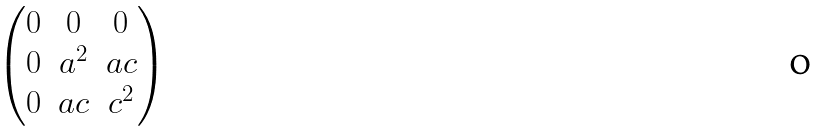Convert formula to latex. <formula><loc_0><loc_0><loc_500><loc_500>\begin{pmatrix} 0 & 0 & 0 \\ 0 & a ^ { 2 } & a c \\ 0 & a c & c ^ { 2 } \\ \end{pmatrix}</formula> 